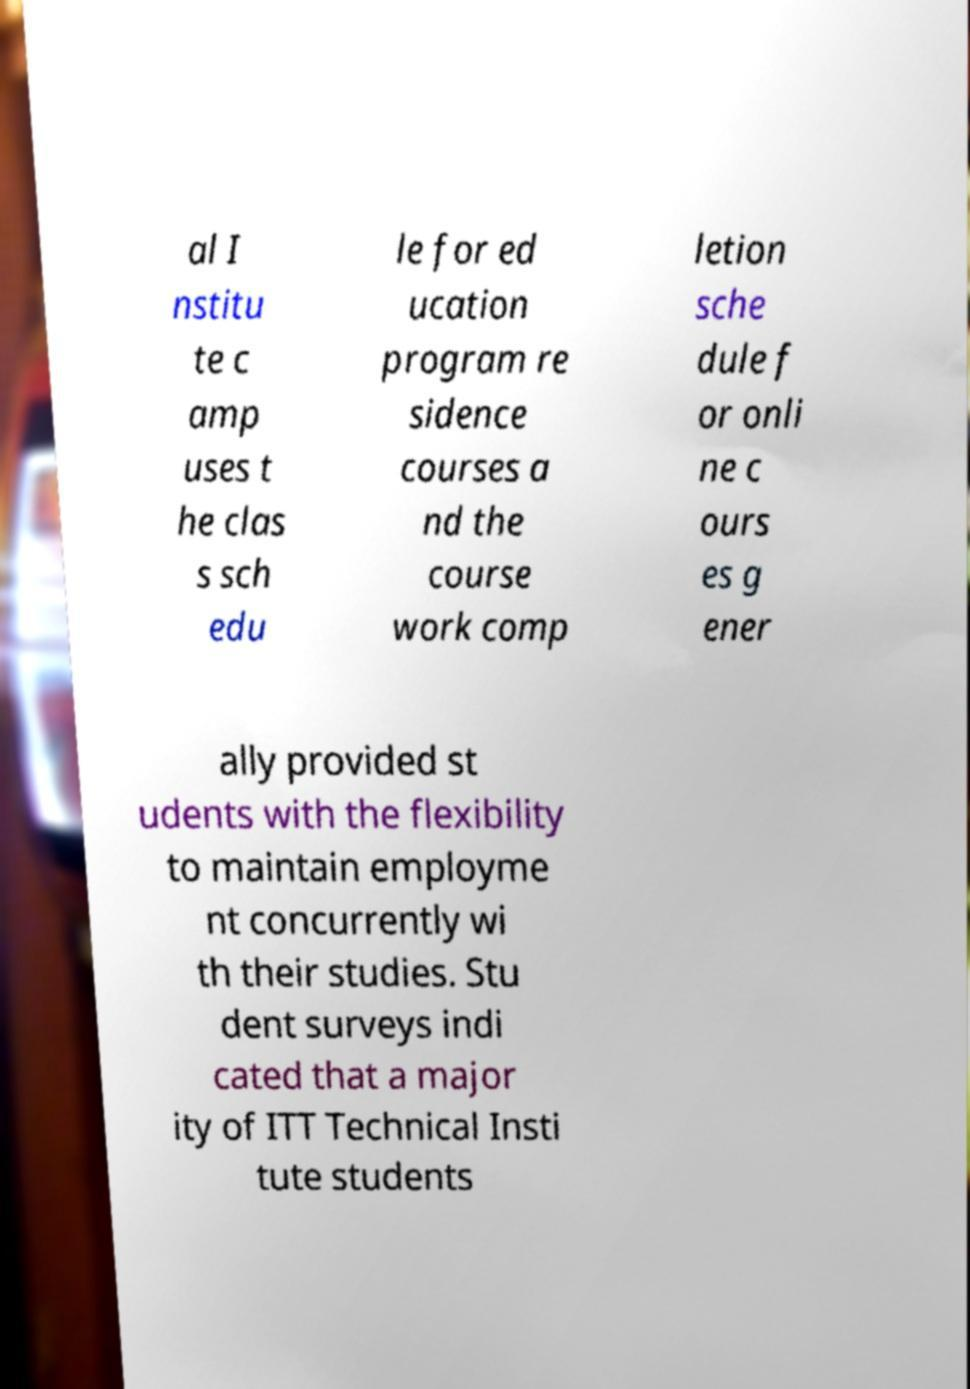For documentation purposes, I need the text within this image transcribed. Could you provide that? al I nstitu te c amp uses t he clas s sch edu le for ed ucation program re sidence courses a nd the course work comp letion sche dule f or onli ne c ours es g ener ally provided st udents with the flexibility to maintain employme nt concurrently wi th their studies. Stu dent surveys indi cated that a major ity of ITT Technical Insti tute students 